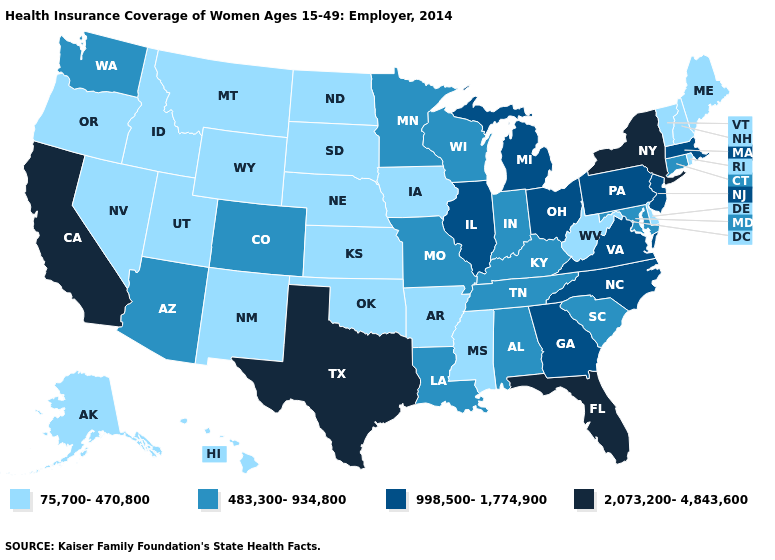Does South Dakota have the lowest value in the USA?
Short answer required. Yes. How many symbols are there in the legend?
Answer briefly. 4. What is the value of Maine?
Write a very short answer. 75,700-470,800. Name the states that have a value in the range 483,300-934,800?
Answer briefly. Alabama, Arizona, Colorado, Connecticut, Indiana, Kentucky, Louisiana, Maryland, Minnesota, Missouri, South Carolina, Tennessee, Washington, Wisconsin. What is the highest value in the USA?
Keep it brief. 2,073,200-4,843,600. What is the value of Michigan?
Quick response, please. 998,500-1,774,900. What is the value of Wisconsin?
Keep it brief. 483,300-934,800. Name the states that have a value in the range 2,073,200-4,843,600?
Quick response, please. California, Florida, New York, Texas. Among the states that border Michigan , does Indiana have the lowest value?
Answer briefly. Yes. What is the value of Oregon?
Quick response, please. 75,700-470,800. Does Montana have a higher value than Nevada?
Write a very short answer. No. Among the states that border Massachusetts , which have the lowest value?
Be succinct. New Hampshire, Rhode Island, Vermont. Name the states that have a value in the range 483,300-934,800?
Short answer required. Alabama, Arizona, Colorado, Connecticut, Indiana, Kentucky, Louisiana, Maryland, Minnesota, Missouri, South Carolina, Tennessee, Washington, Wisconsin. Which states have the lowest value in the MidWest?
Quick response, please. Iowa, Kansas, Nebraska, North Dakota, South Dakota. What is the value of Kentucky?
Be succinct. 483,300-934,800. 